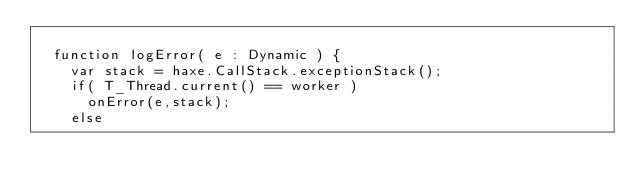Convert code to text. <code><loc_0><loc_0><loc_500><loc_500><_Haxe_>
	function logError( e : Dynamic ) {
		var stack = haxe.CallStack.exceptionStack();
		if( T_Thread.current() == worker )
			onError(e,stack);
		else</code> 